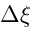Convert formula to latex. <formula><loc_0><loc_0><loc_500><loc_500>\Delta \xi</formula> 